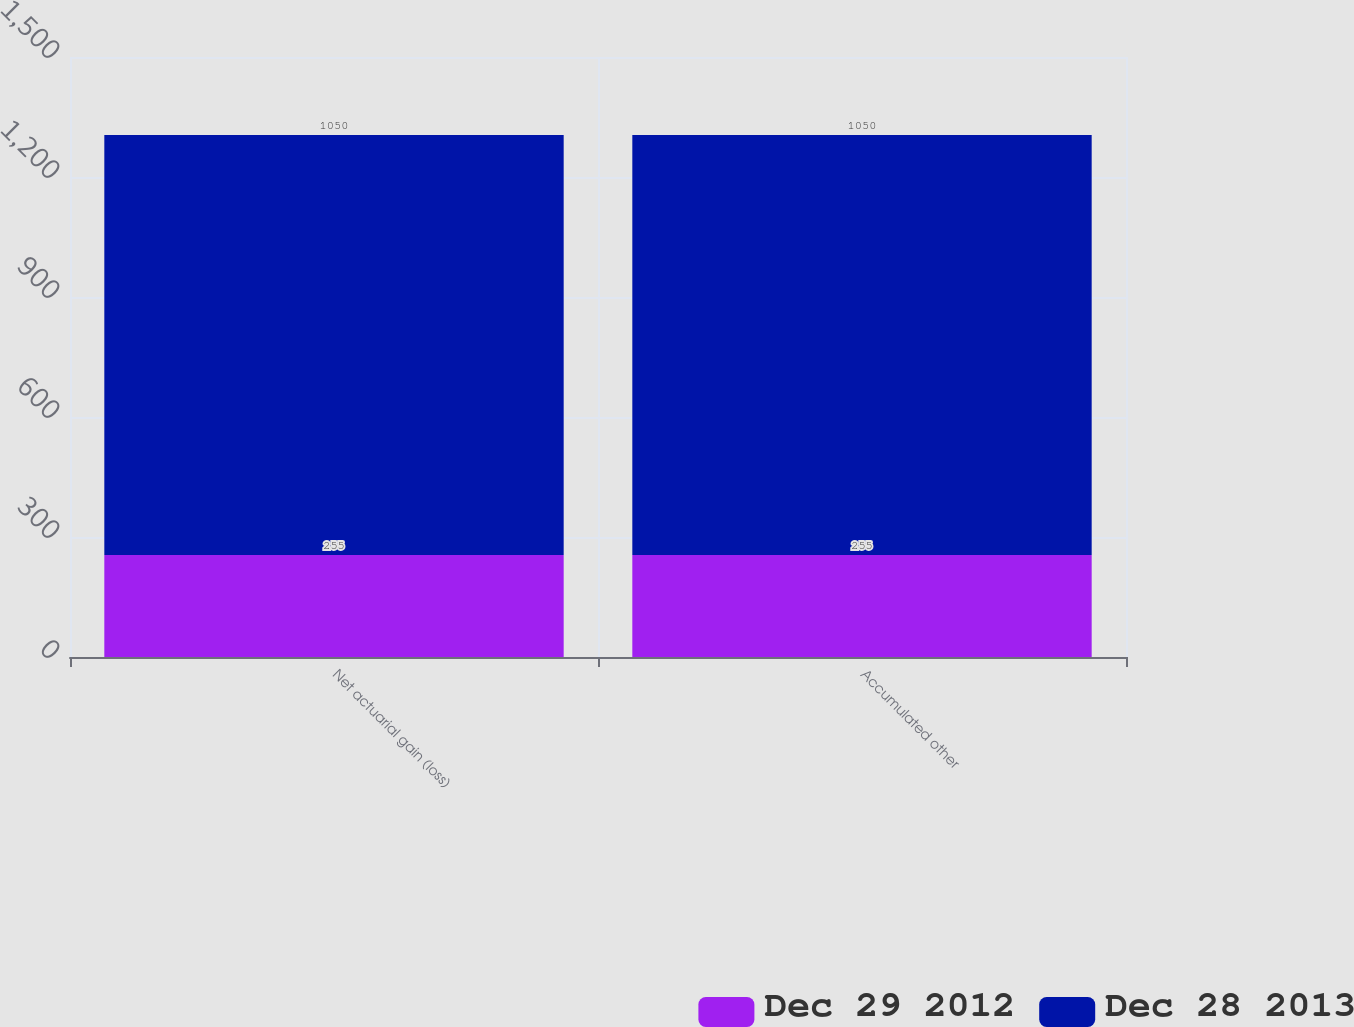Convert chart. <chart><loc_0><loc_0><loc_500><loc_500><stacked_bar_chart><ecel><fcel>Net actuarial gain (loss)<fcel>Accumulated other<nl><fcel>Dec 29 2012<fcel>255<fcel>255<nl><fcel>Dec 28 2013<fcel>1050<fcel>1050<nl></chart> 